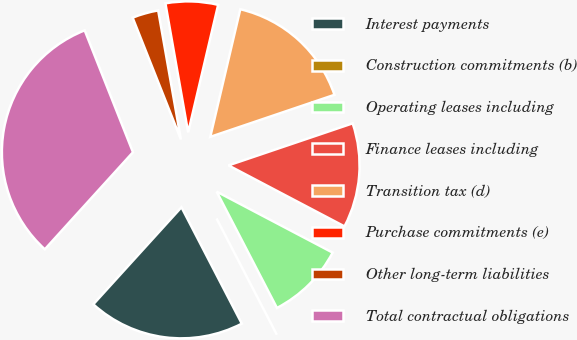Convert chart. <chart><loc_0><loc_0><loc_500><loc_500><pie_chart><fcel>Interest payments<fcel>Construction commitments (b)<fcel>Operating leases including<fcel>Finance leases including<fcel>Transition tax (d)<fcel>Purchase commitments (e)<fcel>Other long-term liabilities<fcel>Total contractual obligations<nl><fcel>19.35%<fcel>0.0%<fcel>9.68%<fcel>12.9%<fcel>16.13%<fcel>6.45%<fcel>3.23%<fcel>32.26%<nl></chart> 